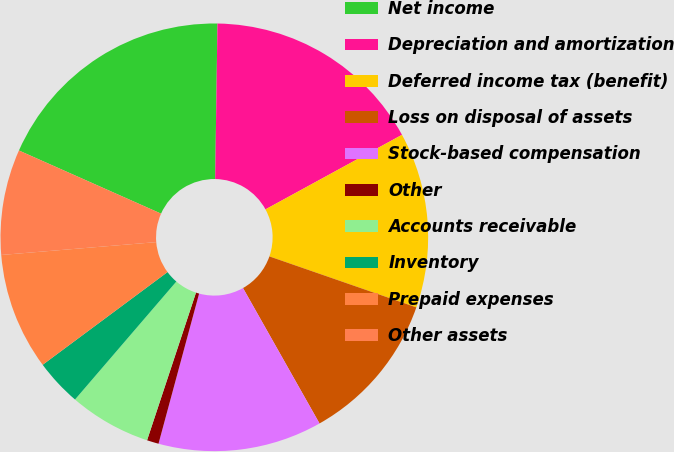Convert chart to OTSL. <chart><loc_0><loc_0><loc_500><loc_500><pie_chart><fcel>Net income<fcel>Depreciation and amortization<fcel>Deferred income tax (benefit)<fcel>Loss on disposal of assets<fcel>Stock-based compensation<fcel>Other<fcel>Accounts receivable<fcel>Inventory<fcel>Prepaid expenses<fcel>Other assets<nl><fcel>18.58%<fcel>16.81%<fcel>13.27%<fcel>11.5%<fcel>12.39%<fcel>0.89%<fcel>6.2%<fcel>3.54%<fcel>8.85%<fcel>7.97%<nl></chart> 